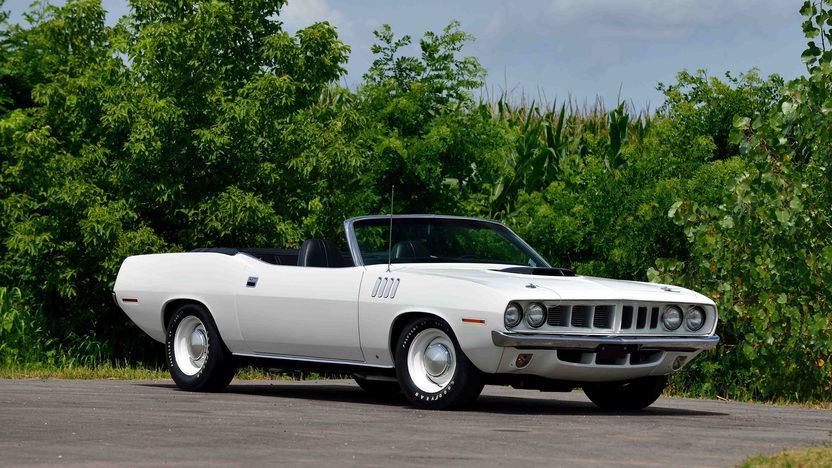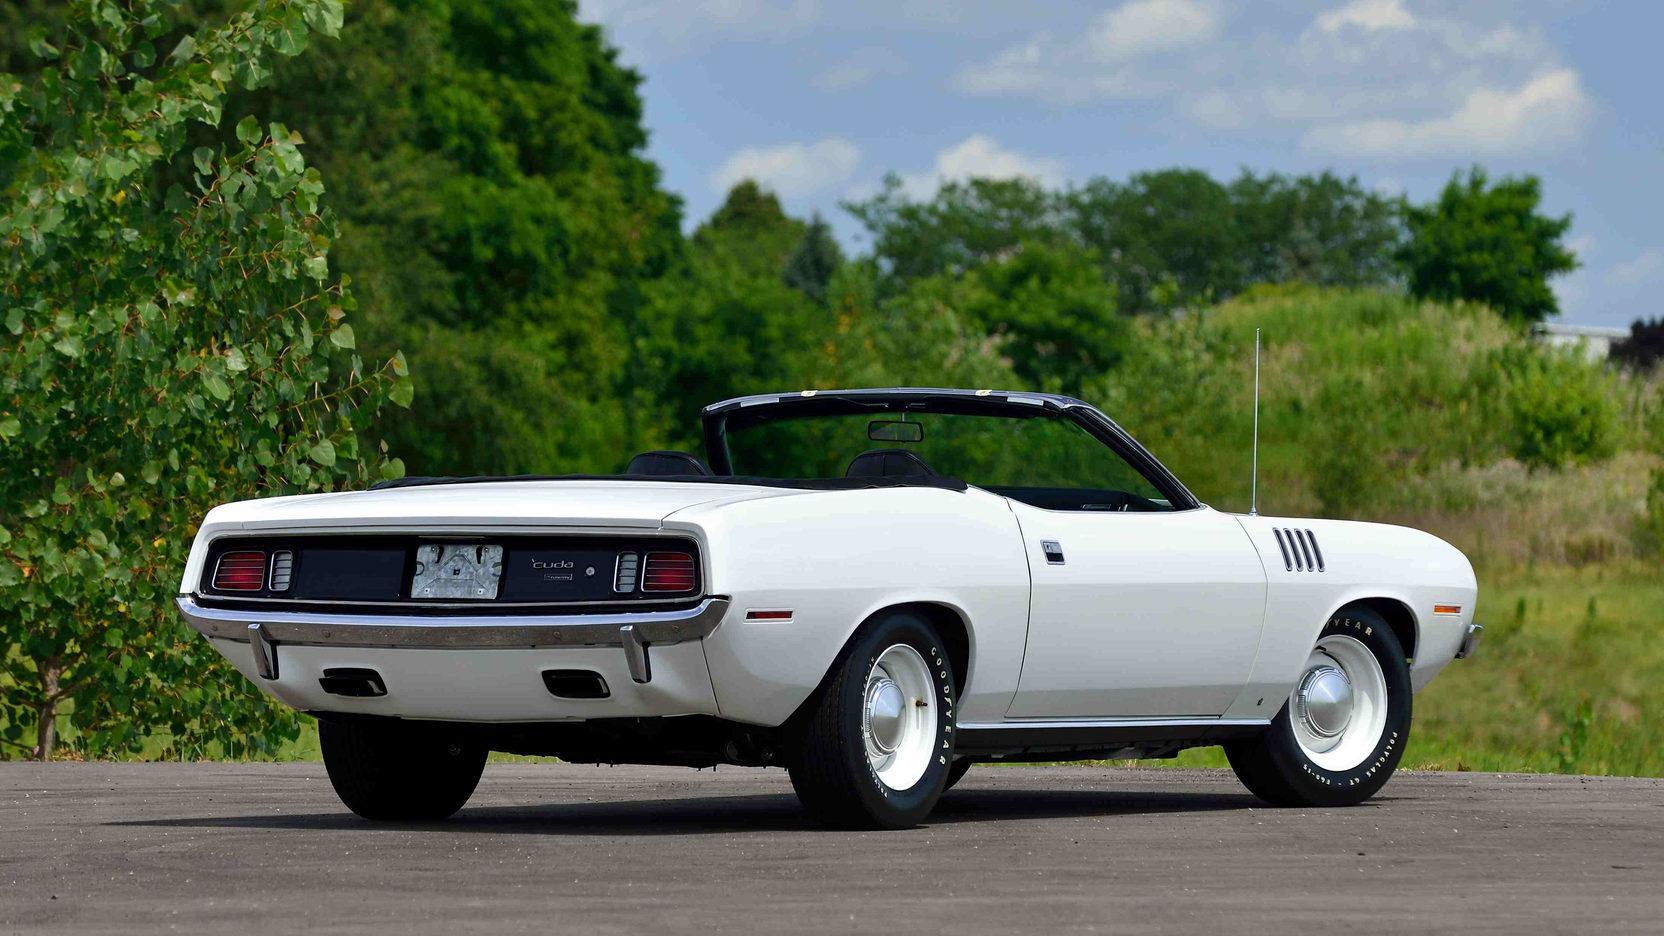The first image is the image on the left, the second image is the image on the right. Examine the images to the left and right. Is the description "Two predominantly white convertibles have the tops down, one facing towards the front and one to the back." accurate? Answer yes or no. Yes. 